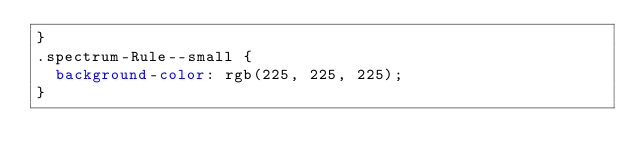Convert code to text. <code><loc_0><loc_0><loc_500><loc_500><_CSS_>}
.spectrum-Rule--small {
  background-color: rgb(225, 225, 225);
}
</code> 